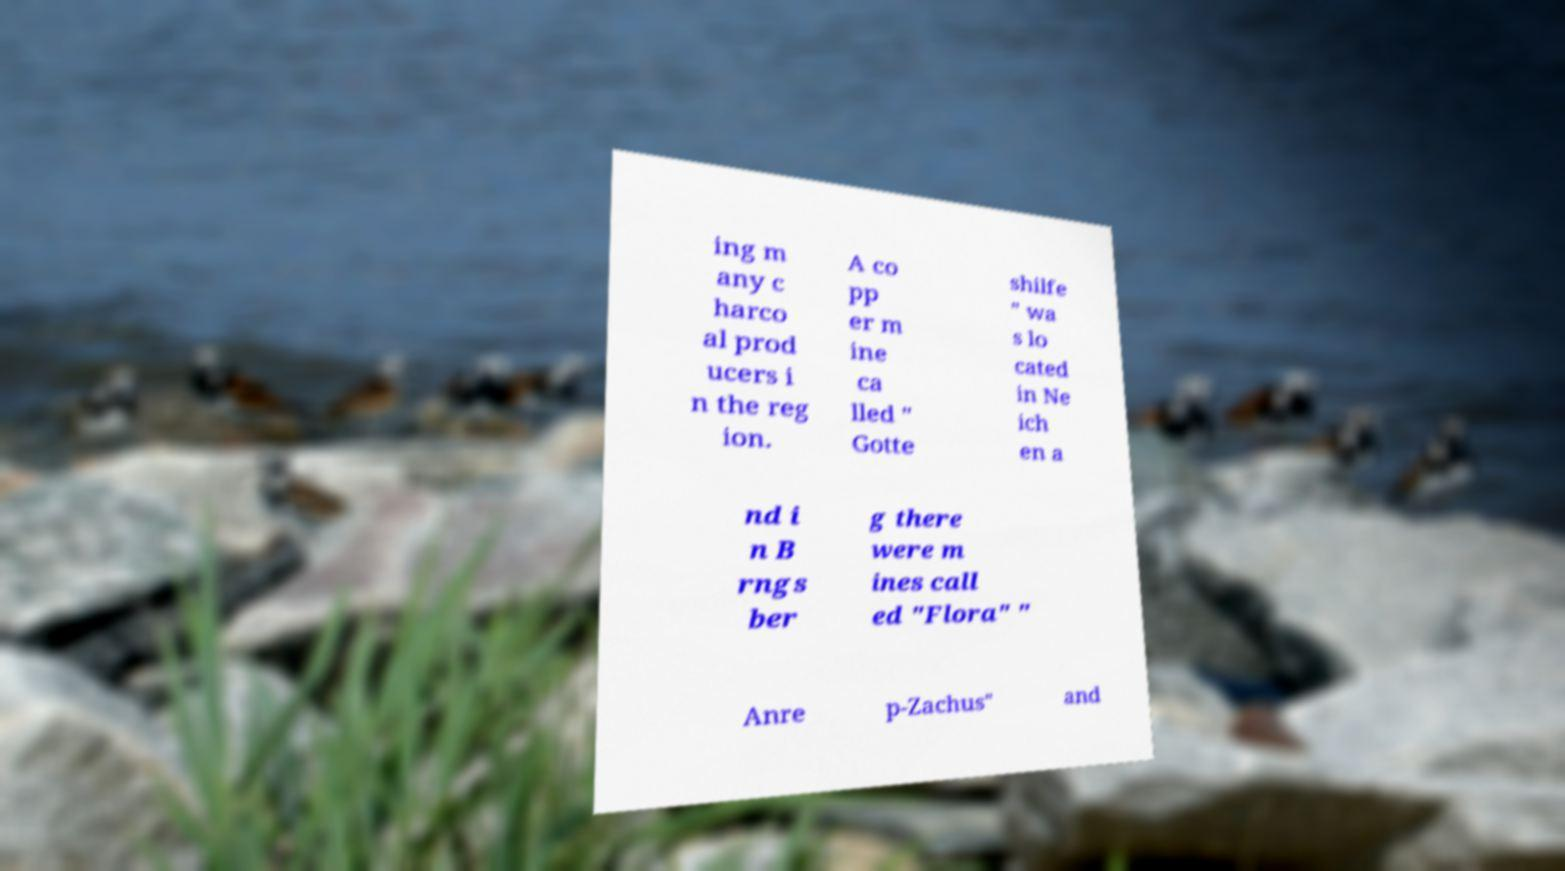I need the written content from this picture converted into text. Can you do that? ing m any c harco al prod ucers i n the reg ion. A co pp er m ine ca lled " Gotte shilfe " wa s lo cated in Ne ich en a nd i n B rngs ber g there were m ines call ed "Flora" " Anre p-Zachus" and 